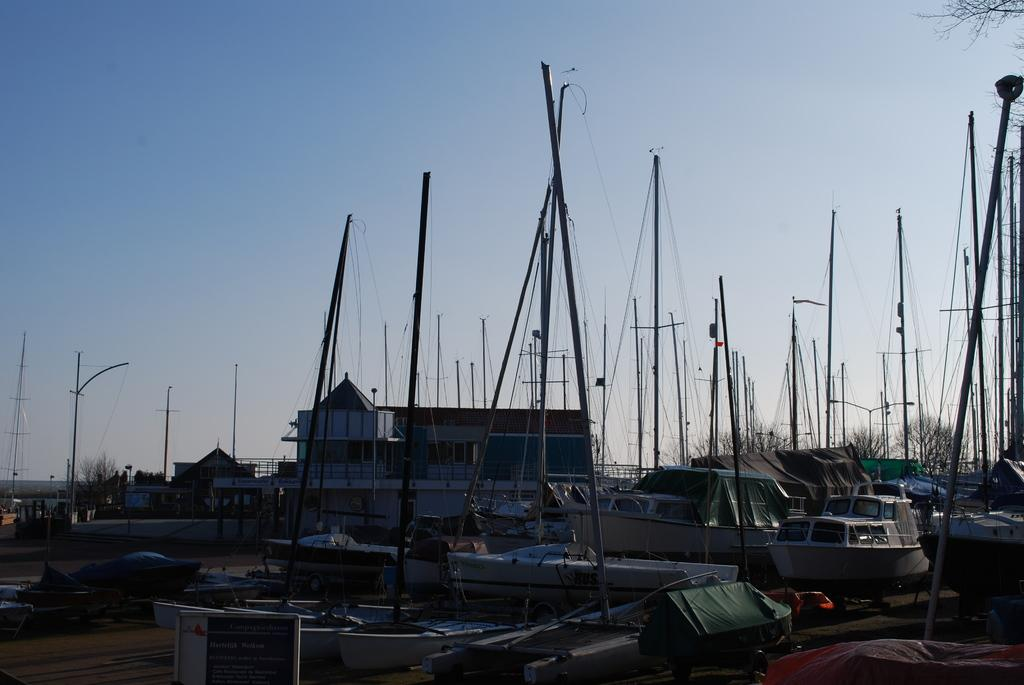What is the main subject of the image? The main subject of the image is many boats. Are there any structures visible in the image? Yes, there is a house in the image. What can be seen in the background of the image? There are trees and the sky visible in the background of the image. Can you hear the sound of people laughing in the image? There is no sound present in the image, so it is not possible to hear any laughter. 